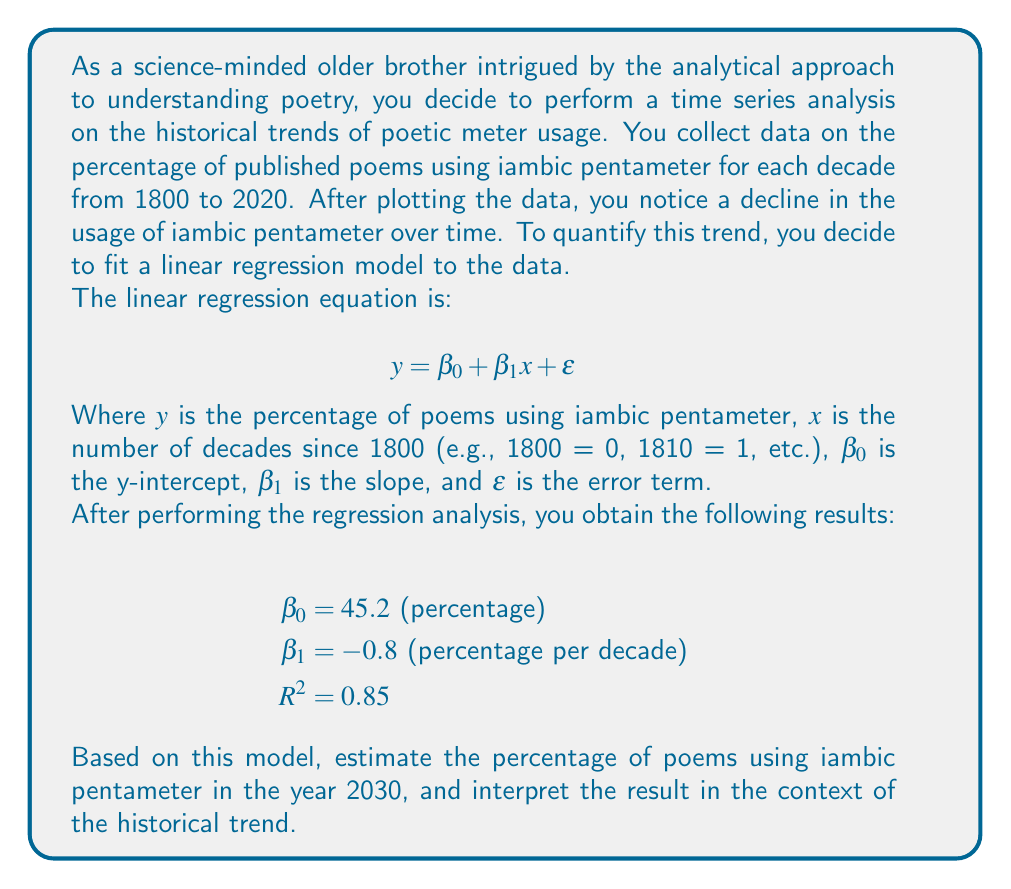Give your solution to this math problem. To solve this problem, we'll follow these steps:

1. Understand the linear regression model and its components.
2. Calculate the number of decades from 1800 to 2030.
3. Use the regression equation to estimate the percentage for 2030.
4. Interpret the result in the context of the historical trend.

Step 1: Understanding the model
The linear regression equation is:

$$ y = 45.2 - 0.8x $$

Where $y$ is the estimated percentage of poems using iambic pentameter, and $x$ is the number of decades since 1800.

Step 2: Calculate decades from 1800 to 2030
Number of decades = (2030 - 1800) / 10 = 23 decades

Step 3: Estimate the percentage for 2030
Substituting $x = 23$ into the equation:

$$ y = 45.2 - 0.8(23) = 45.2 - 18.4 = 26.8\% $$

Step 4: Interpretation
The model estimates that in 2030, approximately 26.8% of published poems will use iambic pentameter. This continues the declining trend observed in the data, with a decrease of 0.8 percentage points per decade.

The $R^2$ value of 0.85 indicates that the model explains 85% of the variance in the data, suggesting a strong fit and supporting the validity of the trend.

Interpreting the historical trend:
1. In 1800 ($x = 0$), the model estimates 45.2% of poems used iambic pentameter.
2. The negative slope ($\beta_1 = -0.8$) indicates a consistent decline in iambic pentameter usage over time.
3. The trend suggests a shift in poetic preferences or styles over the past two centuries, moving away from traditional forms like iambic pentameter.

This analysis provides a quantitative basis for understanding the evolution of poetic meter usage, allowing for a more analytical approach to studying poetry trends.
Answer: The estimated percentage of poems using iambic pentameter in 2030 is 26.8%. This result continues the observed declining trend in iambic pentameter usage, with a decrease of 0.8 percentage points per decade since 1800. 